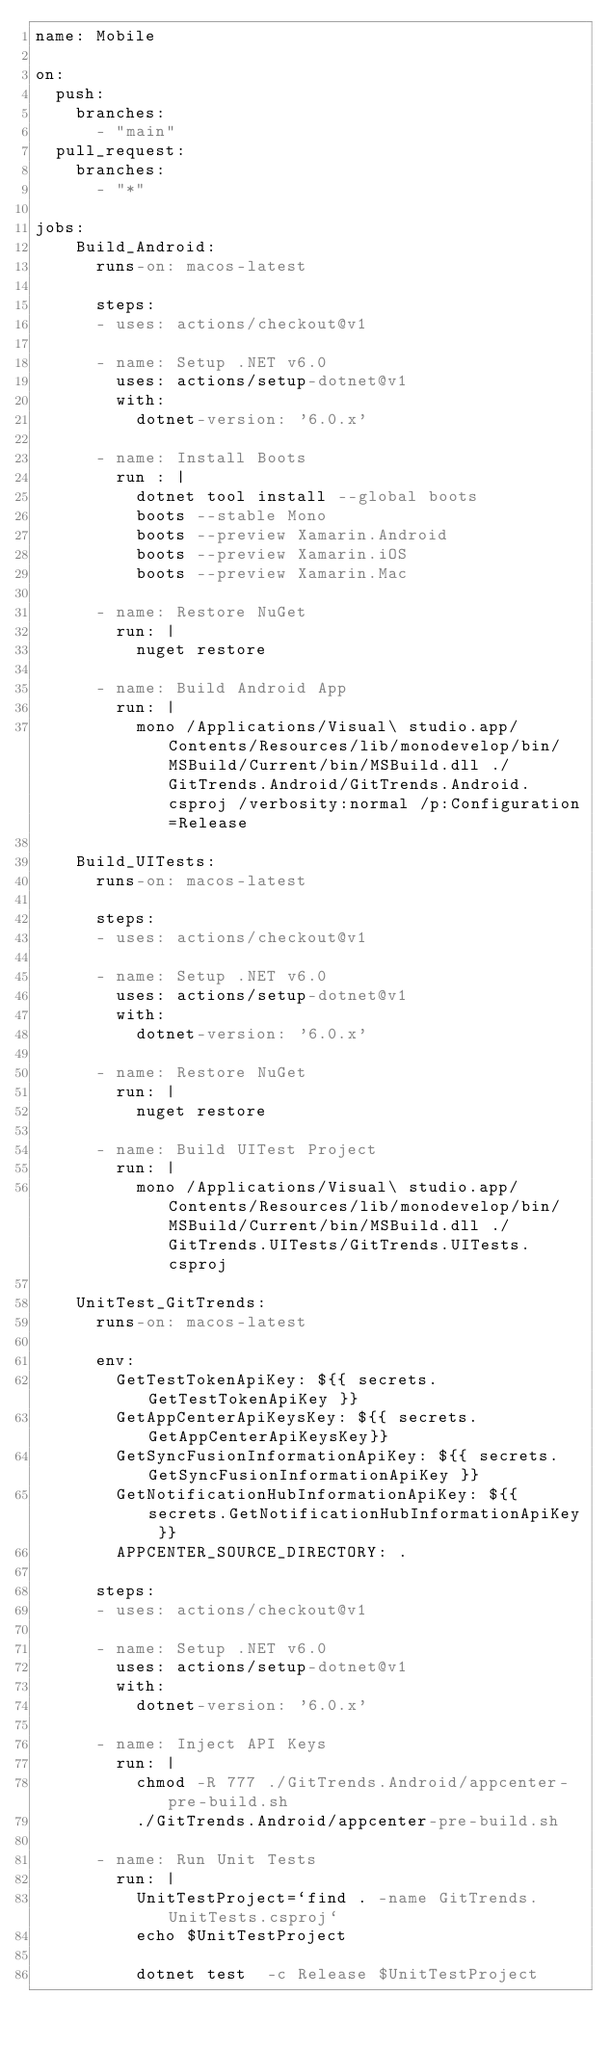<code> <loc_0><loc_0><loc_500><loc_500><_YAML_>name: Mobile

on:
  push:
    branches:
      - "main"
  pull_request:
    branches: 
      - "*"

jobs:
    Build_Android:
      runs-on: macos-latest

      steps:
      - uses: actions/checkout@v1

      - name: Setup .NET v6.0
        uses: actions/setup-dotnet@v1
        with:
          dotnet-version: '6.0.x'

      - name: Install Boots
        run : |
          dotnet tool install --global boots
          boots --stable Mono
          boots --preview Xamarin.Android
          boots --preview Xamarin.iOS
          boots --preview Xamarin.Mac

      - name: Restore NuGet 
        run: |
          nuget restore
          
      - name: Build Android App
        run: |                    
          mono /Applications/Visual\ studio.app/Contents/Resources/lib/monodevelop/bin/MSBuild/Current/bin/MSBuild.dll ./GitTrends.Android/GitTrends.Android.csproj /verbosity:normal /p:Configuration=Release     
          
    Build_UITests:
      runs-on: macos-latest

      steps:
      - uses: actions/checkout@v1

      - name: Setup .NET v6.0
        uses: actions/setup-dotnet@v1
        with:
          dotnet-version: '6.0.x'

      - name: Restore NuGet 
        run: |
          nuget restore
          
      - name: Build UITest Project
        run: |                    
          mono /Applications/Visual\ studio.app/Contents/Resources/lib/monodevelop/bin/MSBuild/Current/bin/MSBuild.dll ./GitTrends.UITests/GitTrends.UITests.csproj   
  
    UnitTest_GitTrends:
      runs-on: macos-latest

      env:
        GetTestTokenApiKey: ${{ secrets.GetTestTokenApiKey }}
        GetAppCenterApiKeysKey: ${{ secrets.GetAppCenterApiKeysKey}}
        GetSyncFusionInformationApiKey: ${{ secrets.GetSyncFusionInformationApiKey }}
        GetNotificationHubInformationApiKey: ${{ secrets.GetNotificationHubInformationApiKey }}
        APPCENTER_SOURCE_DIRECTORY: .

      steps:
      - uses: actions/checkout@v1

      - name: Setup .NET v6.0
        uses: actions/setup-dotnet@v1
        with:
          dotnet-version: '6.0.x'

      - name: Inject API Keys
        run: |
          chmod -R 777 ./GitTrends.Android/appcenter-pre-build.sh
          ./GitTrends.Android/appcenter-pre-build.sh
          
      - name: Run Unit Tests
        run: |   
          UnitTestProject=`find . -name GitTrends.UnitTests.csproj`
          echo $UnitTestProject
          
          dotnet test  -c Release $UnitTestProject</code> 